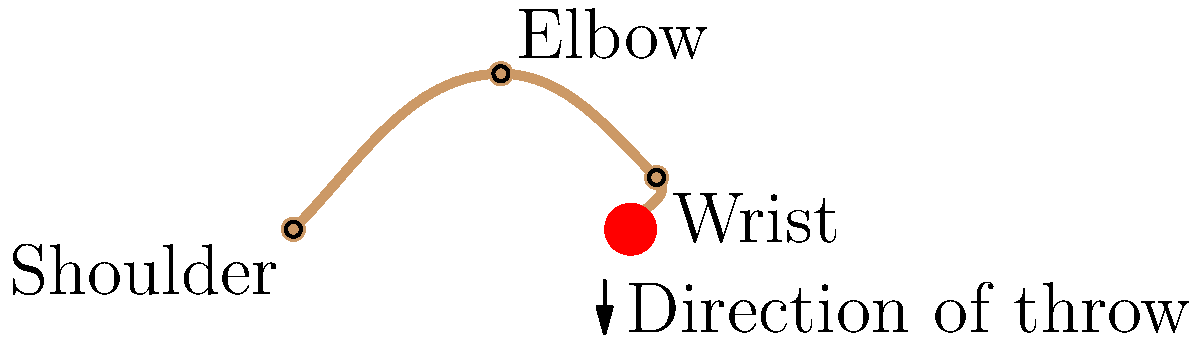As a documentary reviewer specializing in sports science, you're analyzing a film about baseball pitching techniques. The documentary focuses on the biomechanics of throwing a baseball, particularly the arm and shoulder movements. Which phase of the throwing motion is depicted in the provided diagram, and what is its significance in generating maximum velocity for the pitch? To answer this question, let's break down the throwing motion and analyze the diagram:

1. The throwing motion in baseball typically consists of six phases: wind-up, stride, arm cocking, arm acceleration, arm deceleration, and follow-through.

2. The diagram shows the arm in an extended position with the elbow bent and the hand holding the ball behind the pitcher's body.

3. This position is characteristic of the arm acceleration phase, which occurs immediately after the arm cocking phase.

4. During the arm acceleration phase:
   a) The shoulder internally rotates at high angular velocities (up to 7000°/second).
   b) The elbow extends rapidly.
   c) The wrist flexes to impart final velocity to the ball.

5. This phase is crucial for generating maximum pitch velocity because:
   a) It utilizes the energy stored in the stretched muscles and tendons during the previous phases.
   b) It involves a kinetic chain, transferring energy from the larger body segments (trunk and shoulder) to the smaller, faster-moving segments (forearm and hand).
   c) The rapid internal rotation of the shoulder and extension of the elbow create a whip-like effect, maximizing ball velocity at release.

6. The arm acceleration phase is typically the shortest phase of the throwing motion, lasting only about 50 milliseconds.

7. Proper biomechanics during this phase not only maximize pitch velocity but also help distribute stress across multiple joints, potentially reducing injury risk.
Answer: Arm acceleration phase; critical for maximizing pitch velocity through rapid shoulder rotation and elbow extension. 